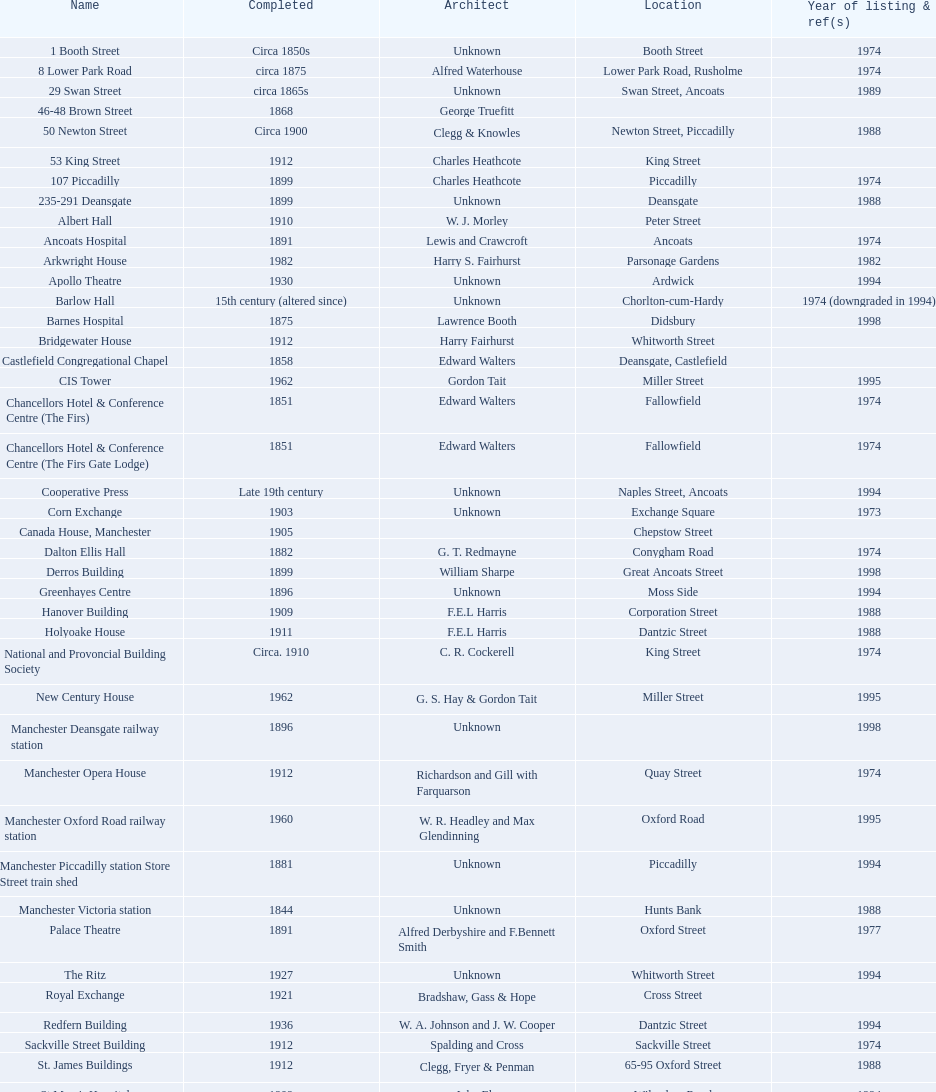Which year has the most buildings listed? 1974. 